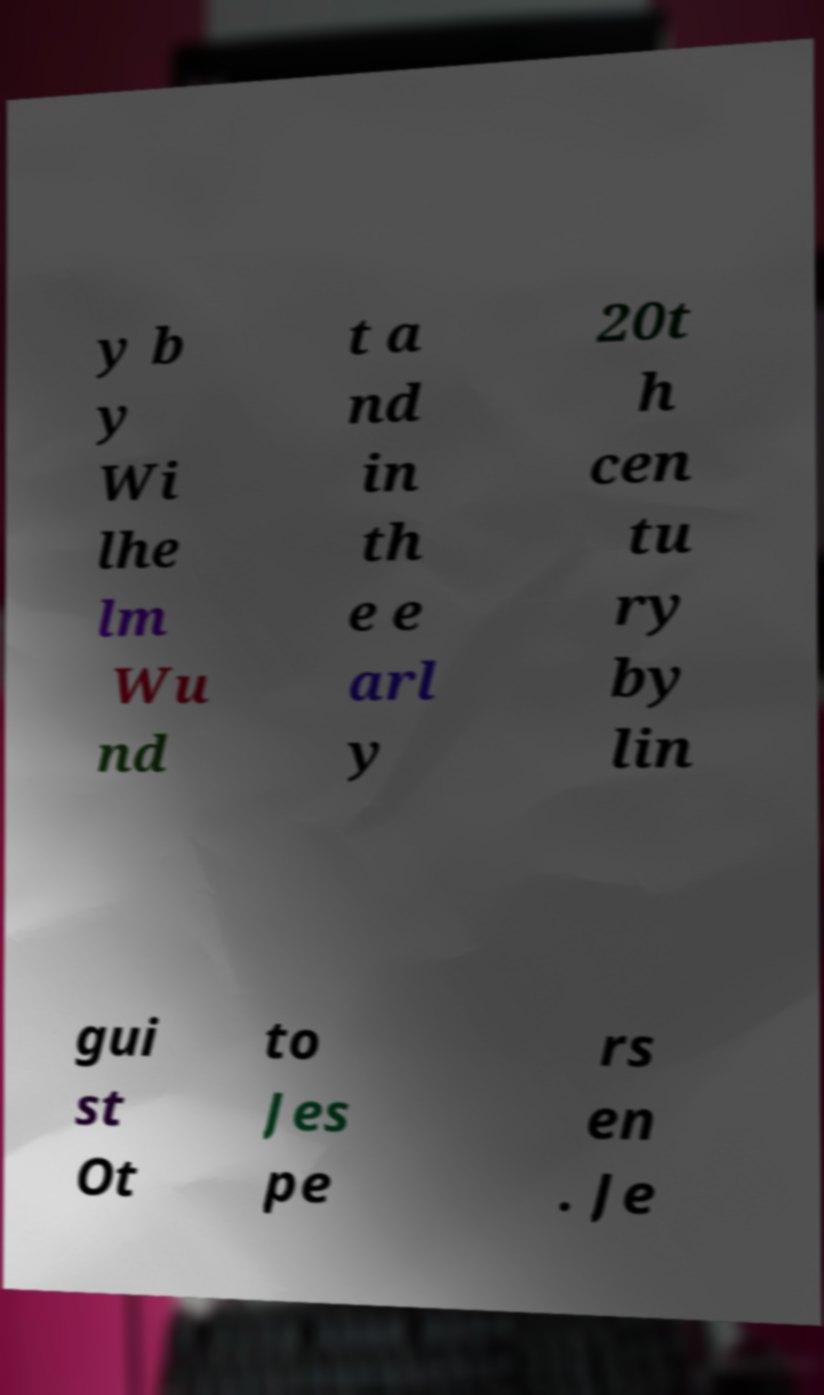Please identify and transcribe the text found in this image. y b y Wi lhe lm Wu nd t a nd in th e e arl y 20t h cen tu ry by lin gui st Ot to Jes pe rs en . Je 